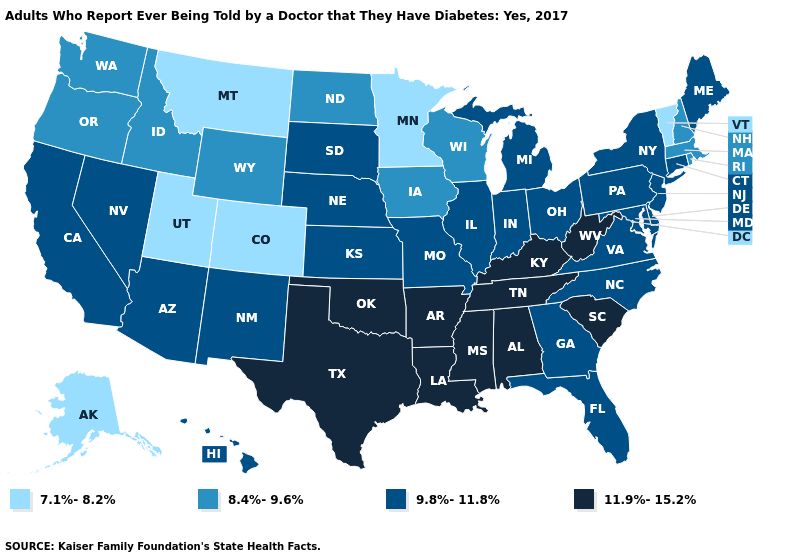Which states have the lowest value in the Northeast?
Keep it brief. Vermont. Name the states that have a value in the range 7.1%-8.2%?
Short answer required. Alaska, Colorado, Minnesota, Montana, Utah, Vermont. Which states have the highest value in the USA?
Answer briefly. Alabama, Arkansas, Kentucky, Louisiana, Mississippi, Oklahoma, South Carolina, Tennessee, Texas, West Virginia. Does California have a higher value than Oklahoma?
Keep it brief. No. What is the value of Nebraska?
Quick response, please. 9.8%-11.8%. Does the map have missing data?
Quick response, please. No. Does Utah have the lowest value in the West?
Be succinct. Yes. Name the states that have a value in the range 9.8%-11.8%?
Quick response, please. Arizona, California, Connecticut, Delaware, Florida, Georgia, Hawaii, Illinois, Indiana, Kansas, Maine, Maryland, Michigan, Missouri, Nebraska, Nevada, New Jersey, New Mexico, New York, North Carolina, Ohio, Pennsylvania, South Dakota, Virginia. Which states have the lowest value in the USA?
Quick response, please. Alaska, Colorado, Minnesota, Montana, Utah, Vermont. What is the lowest value in the West?
Short answer required. 7.1%-8.2%. What is the value of Utah?
Be succinct. 7.1%-8.2%. What is the value of Minnesota?
Concise answer only. 7.1%-8.2%. Does Georgia have a higher value than Vermont?
Write a very short answer. Yes. Does Louisiana have the highest value in the USA?
Keep it brief. Yes. Name the states that have a value in the range 11.9%-15.2%?
Be succinct. Alabama, Arkansas, Kentucky, Louisiana, Mississippi, Oklahoma, South Carolina, Tennessee, Texas, West Virginia. 